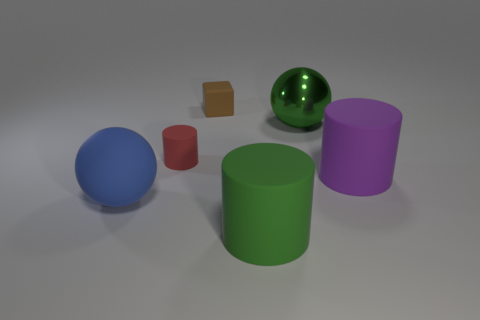Add 2 blue rubber objects. How many objects exist? 8 Subtract all cubes. How many objects are left? 5 Add 2 big brown shiny objects. How many big brown shiny objects exist? 2 Subtract 0 red balls. How many objects are left? 6 Subtract all brown blocks. Subtract all purple rubber objects. How many objects are left? 4 Add 1 small red cylinders. How many small red cylinders are left? 2 